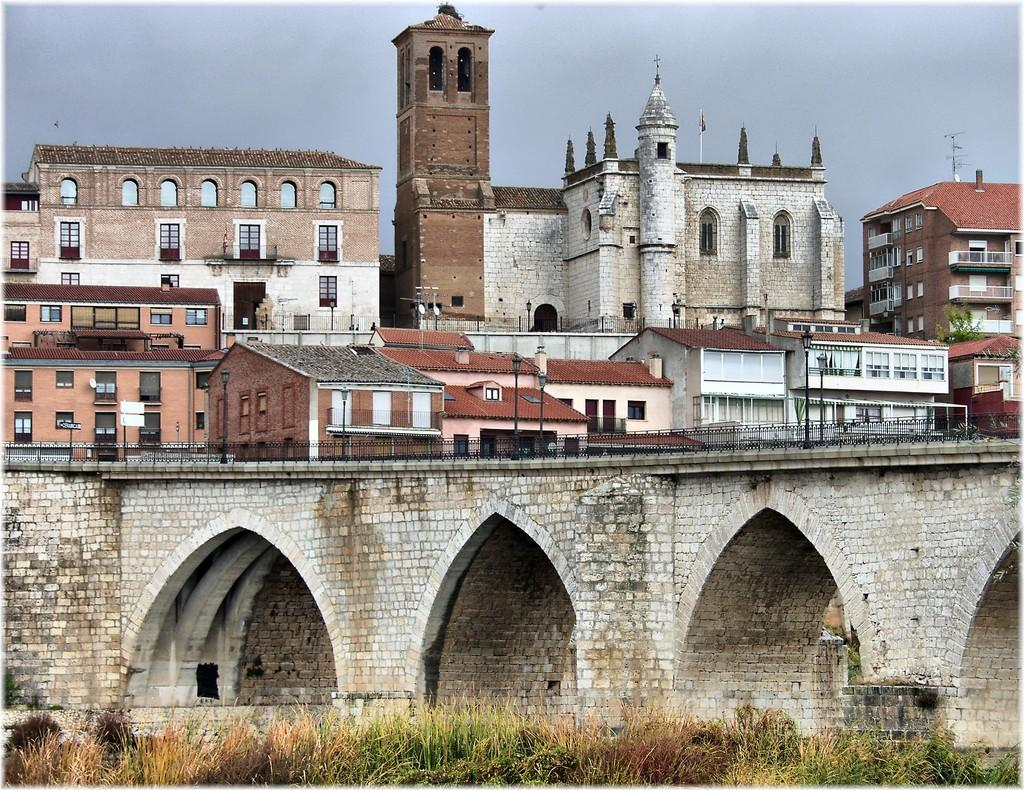What celestial bodies can be seen in the image? There are planets in the image. What type of structure is present in the image? There is a bridge in the image. What type of buildings are visible in the image? There are buildings with windows in the image. What else can be seen in the image besides the celestial bodies and structures? There are some objects in the image. What is visible in the background of the image? The sky is visible in the background of the image. How many spiders are crawling on the bridge in the image? There are no spiders present in the image; it features planets, a bridge, buildings, objects, and a sky. What type of stitch is used to create the buildings in the image? The buildings in the image are not made of fabric or any material that requires stitching; they are solid structures. 